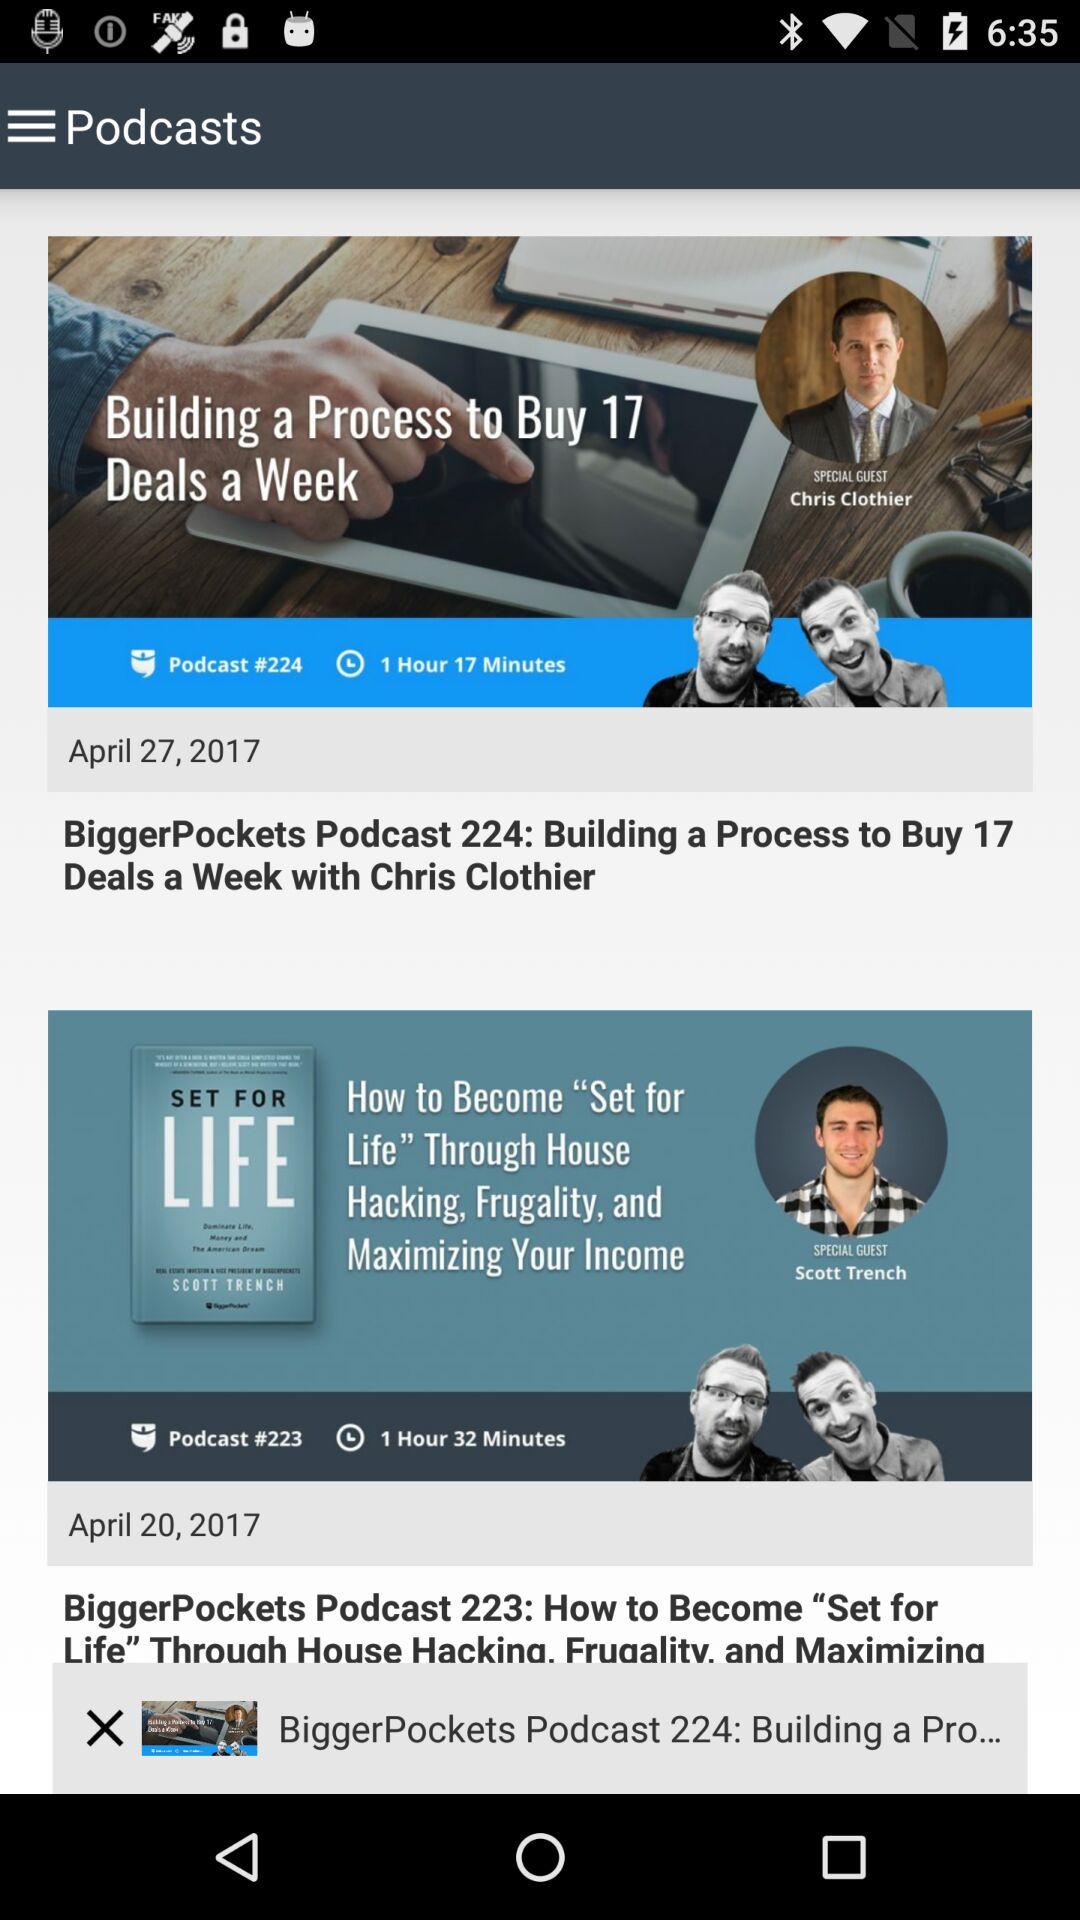When was "BiggerPockets Podcast 224" published? "BiggerPockets Podcast 224" was published on April 27, 2017. 